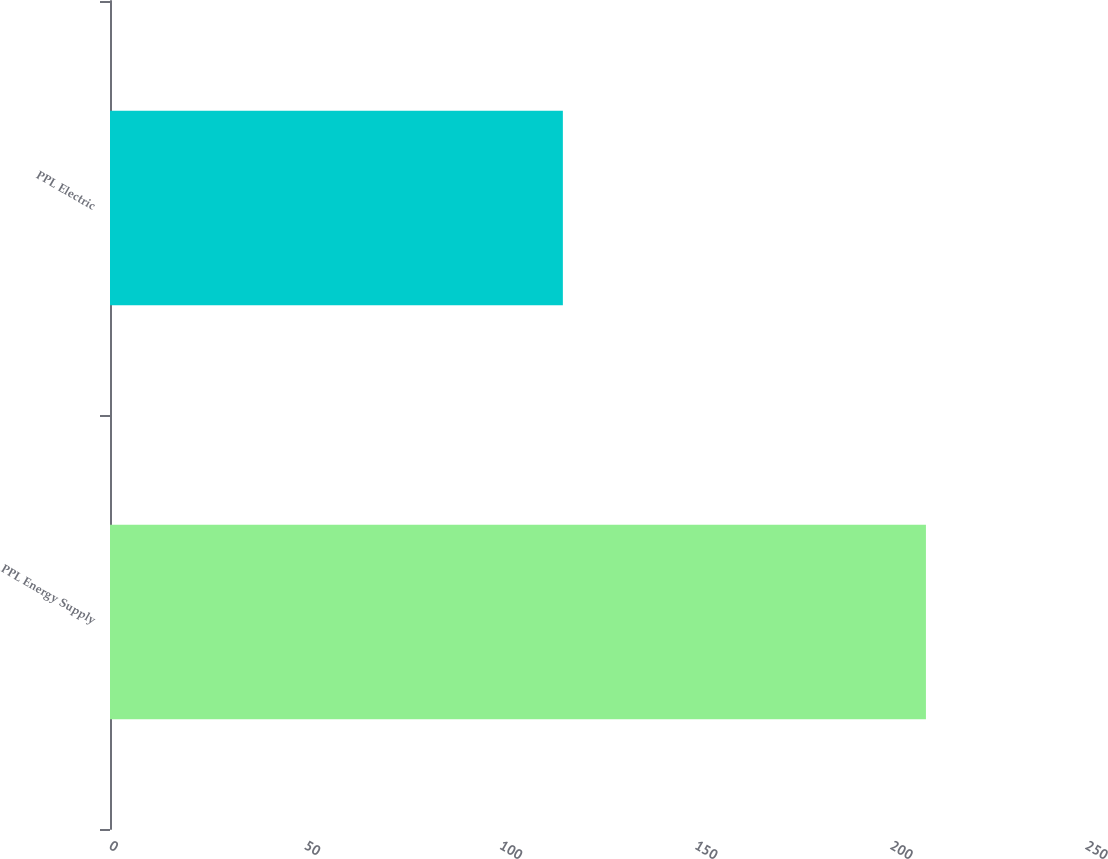Convert chart. <chart><loc_0><loc_0><loc_500><loc_500><bar_chart><fcel>PPL Energy Supply<fcel>PPL Electric<nl><fcel>209<fcel>116<nl></chart> 